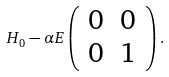Convert formula to latex. <formula><loc_0><loc_0><loc_500><loc_500>H _ { 0 } - \alpha E \left ( \begin{array} { c c } 0 & 0 \\ 0 & 1 \end{array} \right ) .</formula> 